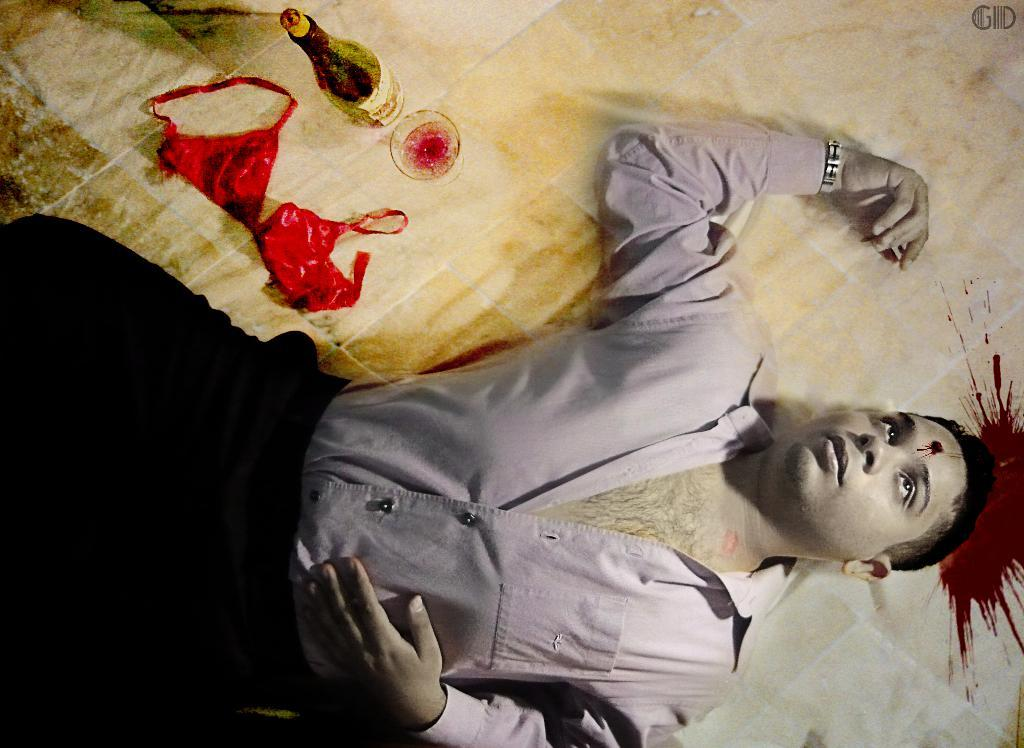What is the position of the man in the image? There is a man lying on the floor in the image. What can be seen on the floor along with the man? There is blood on the floor in the image. What objects are present in the image besides the man and blood? There is a bottle and a glass in the image. What type of clothing item is present in the image? There is a woman's inner wear in the image. What type of creature is causing the sleet in the image? There is no mention of sleet or any creature in the image. The image only shows a man lying on the floor, blood on the floor, a bottle, a glass, and a woman's inner wear. 